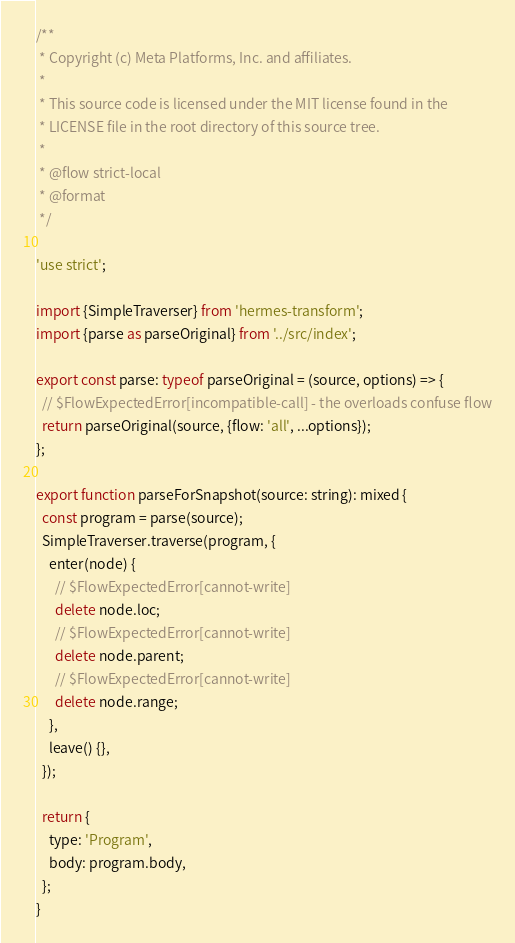Convert code to text. <code><loc_0><loc_0><loc_500><loc_500><_JavaScript_>/**
 * Copyright (c) Meta Platforms, Inc. and affiliates.
 *
 * This source code is licensed under the MIT license found in the
 * LICENSE file in the root directory of this source tree.
 *
 * @flow strict-local
 * @format
 */

'use strict';

import {SimpleTraverser} from 'hermes-transform';
import {parse as parseOriginal} from '../src/index';

export const parse: typeof parseOriginal = (source, options) => {
  // $FlowExpectedError[incompatible-call] - the overloads confuse flow
  return parseOriginal(source, {flow: 'all', ...options});
};

export function parseForSnapshot(source: string): mixed {
  const program = parse(source);
  SimpleTraverser.traverse(program, {
    enter(node) {
      // $FlowExpectedError[cannot-write]
      delete node.loc;
      // $FlowExpectedError[cannot-write]
      delete node.parent;
      // $FlowExpectedError[cannot-write]
      delete node.range;
    },
    leave() {},
  });

  return {
    type: 'Program',
    body: program.body,
  };
}
</code> 